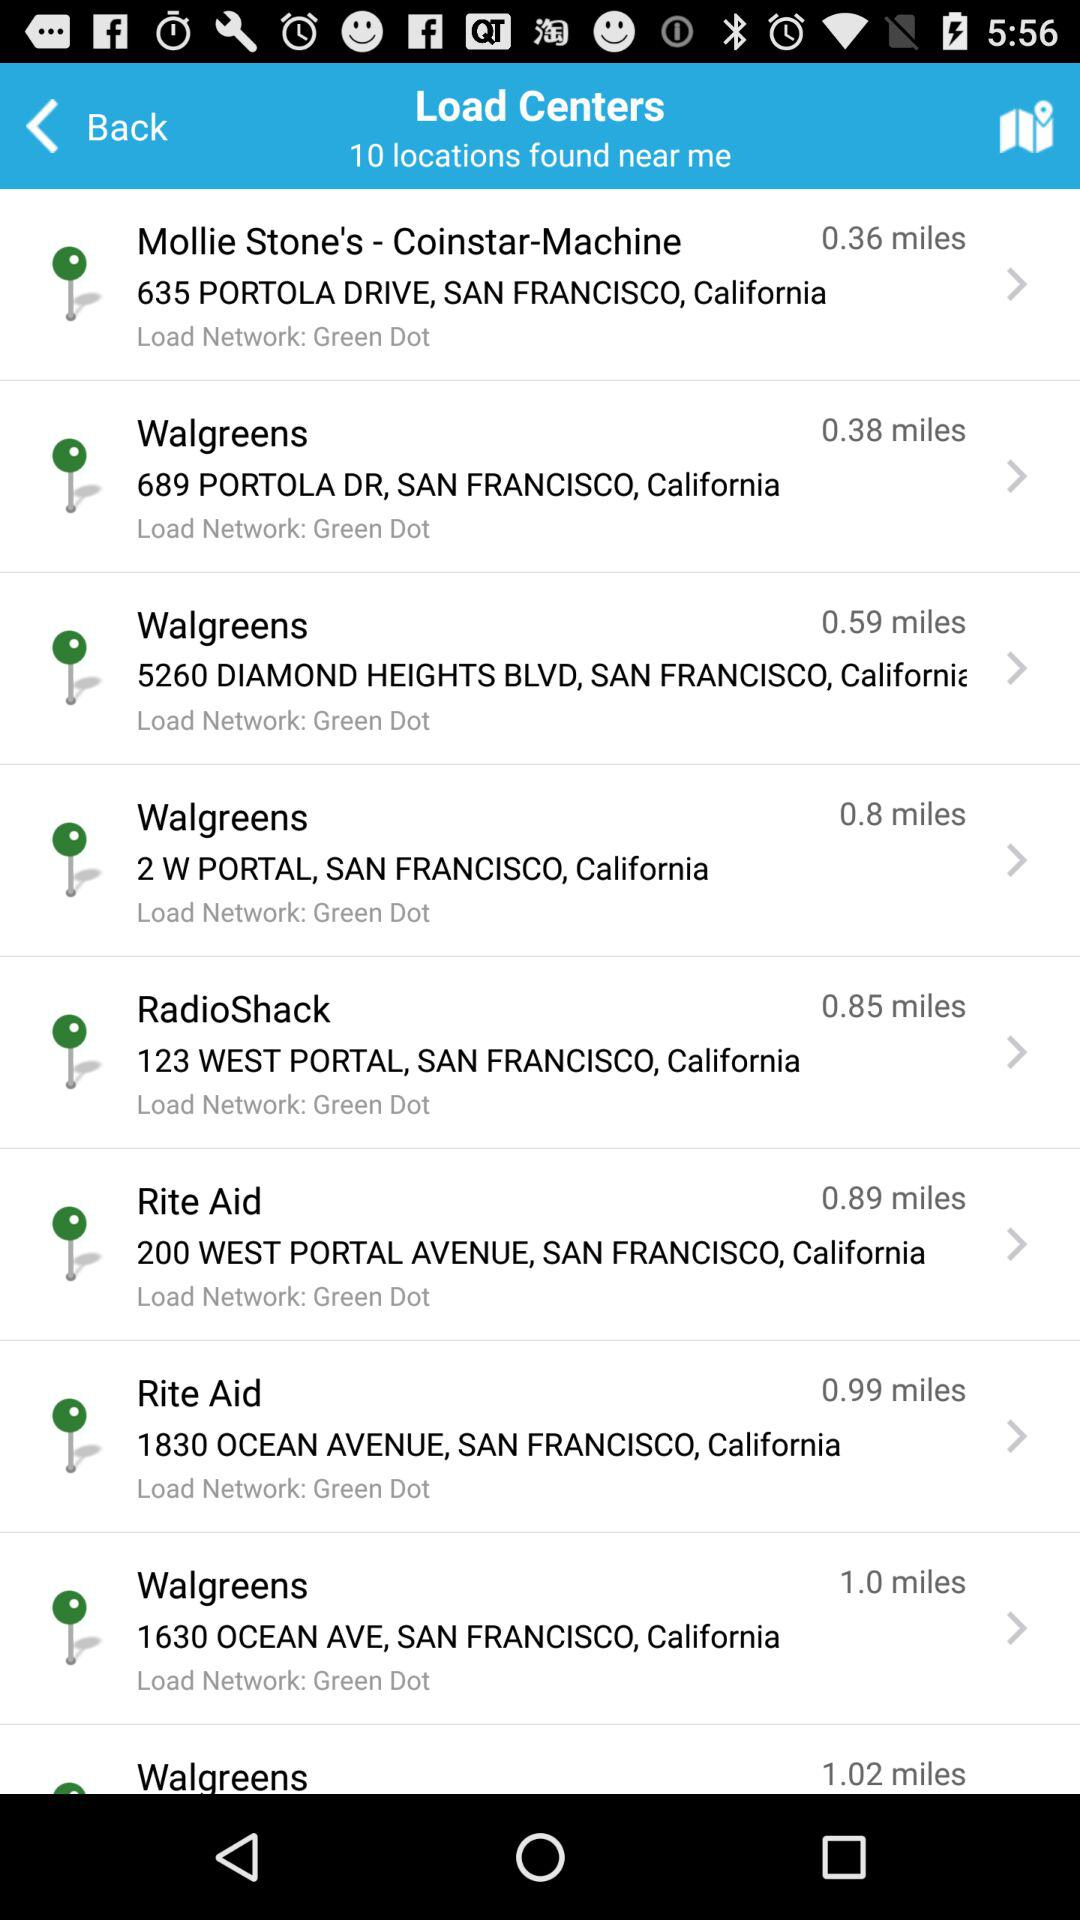What is the distance of the "RadioShack" from the source? The distance of the "RadioShack" from the source is 0.85 miles. 